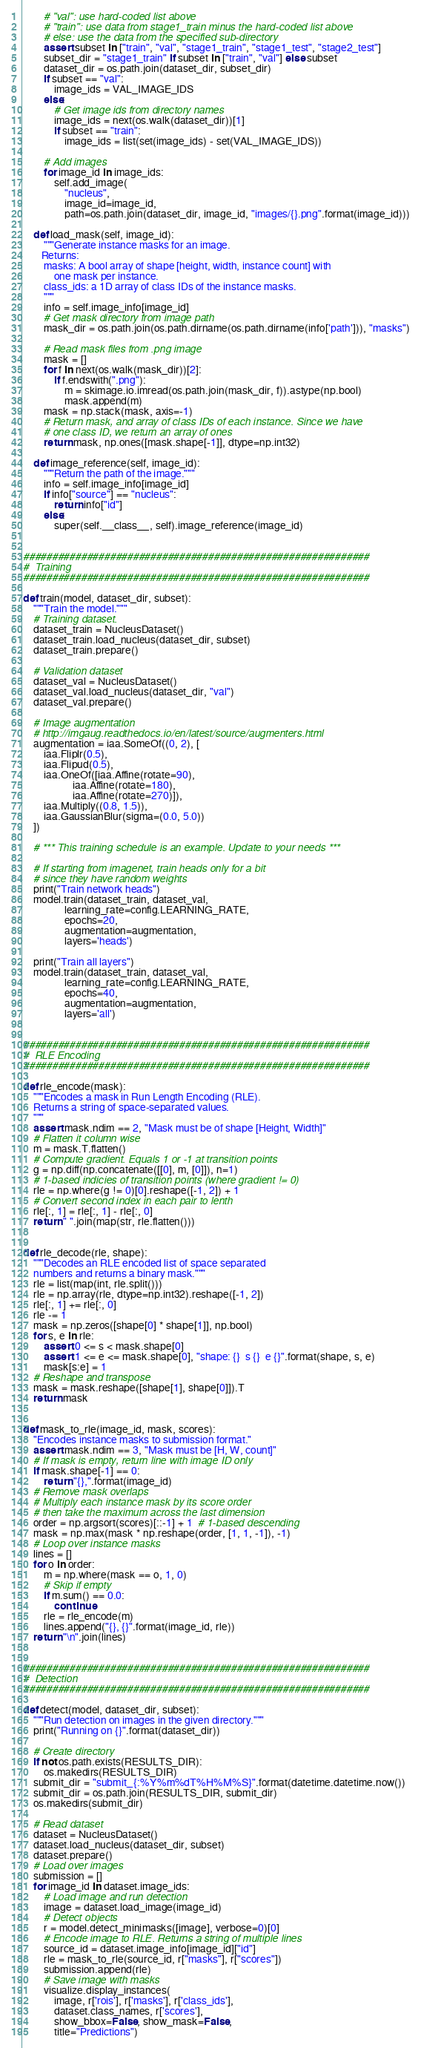<code> <loc_0><loc_0><loc_500><loc_500><_Python_>        # "val": use hard-coded list above
        # "train": use data from stage1_train minus the hard-coded list above
        # else: use the data from the specified sub-directory
        assert subset in ["train", "val", "stage1_train", "stage1_test", "stage2_test"]
        subset_dir = "stage1_train" if subset in ["train", "val"] else subset
        dataset_dir = os.path.join(dataset_dir, subset_dir)
        if subset == "val":
            image_ids = VAL_IMAGE_IDS
        else:
            # Get image ids from directory names
            image_ids = next(os.walk(dataset_dir))[1]
            if subset == "train":
                image_ids = list(set(image_ids) - set(VAL_IMAGE_IDS))

        # Add images
        for image_id in image_ids:
            self.add_image(
                "nucleus",
                image_id=image_id,
                path=os.path.join(dataset_dir, image_id, "images/{}.png".format(image_id)))

    def load_mask(self, image_id):
        """Generate instance masks for an image.
       Returns:
        masks: A bool array of shape [height, width, instance count] with
            one mask per instance.
        class_ids: a 1D array of class IDs of the instance masks.
        """
        info = self.image_info[image_id]
        # Get mask directory from image path
        mask_dir = os.path.join(os.path.dirname(os.path.dirname(info['path'])), "masks")

        # Read mask files from .png image
        mask = []
        for f in next(os.walk(mask_dir))[2]:
            if f.endswith(".png"):
                m = skimage.io.imread(os.path.join(mask_dir, f)).astype(np.bool)
                mask.append(m)
        mask = np.stack(mask, axis=-1)
        # Return mask, and array of class IDs of each instance. Since we have
        # one class ID, we return an array of ones
        return mask, np.ones([mask.shape[-1]], dtype=np.int32)

    def image_reference(self, image_id):
        """Return the path of the image."""
        info = self.image_info[image_id]
        if info["source"] == "nucleus":
            return info["id"]
        else:
            super(self.__class__, self).image_reference(image_id)


############################################################
#  Training
############################################################

def train(model, dataset_dir, subset):
    """Train the model."""
    # Training dataset.
    dataset_train = NucleusDataset()
    dataset_train.load_nucleus(dataset_dir, subset)
    dataset_train.prepare()

    # Validation dataset
    dataset_val = NucleusDataset()
    dataset_val.load_nucleus(dataset_dir, "val")
    dataset_val.prepare()

    # Image augmentation
    # http://imgaug.readthedocs.io/en/latest/source/augmenters.html
    augmentation = iaa.SomeOf((0, 2), [
        iaa.Fliplr(0.5),
        iaa.Flipud(0.5),
        iaa.OneOf([iaa.Affine(rotate=90),
                   iaa.Affine(rotate=180),
                   iaa.Affine(rotate=270)]),
        iaa.Multiply((0.8, 1.5)),
        iaa.GaussianBlur(sigma=(0.0, 5.0))
    ])

    # *** This training schedule is an example. Update to your needs ***

    # If starting from imagenet, train heads only for a bit
    # since they have random weights
    print("Train network heads")
    model.train(dataset_train, dataset_val,
                learning_rate=config.LEARNING_RATE,
                epochs=20,
                augmentation=augmentation,
                layers='heads')

    print("Train all layers")
    model.train(dataset_train, dataset_val,
                learning_rate=config.LEARNING_RATE,
                epochs=40,
                augmentation=augmentation,
                layers='all')


############################################################
#  RLE Encoding
############################################################

def rle_encode(mask):
    """Encodes a mask in Run Length Encoding (RLE).
    Returns a string of space-separated values.
    """
    assert mask.ndim == 2, "Mask must be of shape [Height, Width]"
    # Flatten it column wise
    m = mask.T.flatten()
    # Compute gradient. Equals 1 or -1 at transition points
    g = np.diff(np.concatenate([[0], m, [0]]), n=1)
    # 1-based indicies of transition points (where gradient != 0)
    rle = np.where(g != 0)[0].reshape([-1, 2]) + 1
    # Convert second index in each pair to lenth
    rle[:, 1] = rle[:, 1] - rle[:, 0]
    return " ".join(map(str, rle.flatten()))


def rle_decode(rle, shape):
    """Decodes an RLE encoded list of space separated
    numbers and returns a binary mask."""
    rle = list(map(int, rle.split()))
    rle = np.array(rle, dtype=np.int32).reshape([-1, 2])
    rle[:, 1] += rle[:, 0]
    rle -= 1
    mask = np.zeros([shape[0] * shape[1]], np.bool)
    for s, e in rle:
        assert 0 <= s < mask.shape[0]
        assert 1 <= e <= mask.shape[0], "shape: {}  s {}  e {}".format(shape, s, e)
        mask[s:e] = 1
    # Reshape and transpose
    mask = mask.reshape([shape[1], shape[0]]).T
    return mask


def mask_to_rle(image_id, mask, scores):
    "Encodes instance masks to submission format."
    assert mask.ndim == 3, "Mask must be [H, W, count]"
    # If mask is empty, return line with image ID only
    if mask.shape[-1] == 0:
        return "{},".format(image_id)
    # Remove mask overlaps
    # Multiply each instance mask by its score order
    # then take the maximum across the last dimension
    order = np.argsort(scores)[::-1] + 1  # 1-based descending
    mask = np.max(mask * np.reshape(order, [1, 1, -1]), -1)
    # Loop over instance masks
    lines = []
    for o in order:
        m = np.where(mask == o, 1, 0)
        # Skip if empty
        if m.sum() == 0.0:
            continue
        rle = rle_encode(m)
        lines.append("{}, {}".format(image_id, rle))
    return "\n".join(lines)


############################################################
#  Detection
############################################################

def detect(model, dataset_dir, subset):
    """Run detection on images in the given directory."""
    print("Running on {}".format(dataset_dir))

    # Create directory
    if not os.path.exists(RESULTS_DIR):
        os.makedirs(RESULTS_DIR)
    submit_dir = "submit_{:%Y%m%dT%H%M%S}".format(datetime.datetime.now())
    submit_dir = os.path.join(RESULTS_DIR, submit_dir)
    os.makedirs(submit_dir)

    # Read dataset
    dataset = NucleusDataset()
    dataset.load_nucleus(dataset_dir, subset)
    dataset.prepare()
    # Load over images
    submission = []
    for image_id in dataset.image_ids:
        # Load image and run detection
        image = dataset.load_image(image_id)
        # Detect objects
        r = model.detect_minimasks([image], verbose=0)[0]
        # Encode image to RLE. Returns a string of multiple lines
        source_id = dataset.image_info[image_id]["id"]
        rle = mask_to_rle(source_id, r["masks"], r["scores"])
        submission.append(rle)
        # Save image with masks
        visualize.display_instances(
            image, r['rois'], r['masks'], r['class_ids'],
            dataset.class_names, r['scores'],
            show_bbox=False, show_mask=False,
            title="Predictions")</code> 